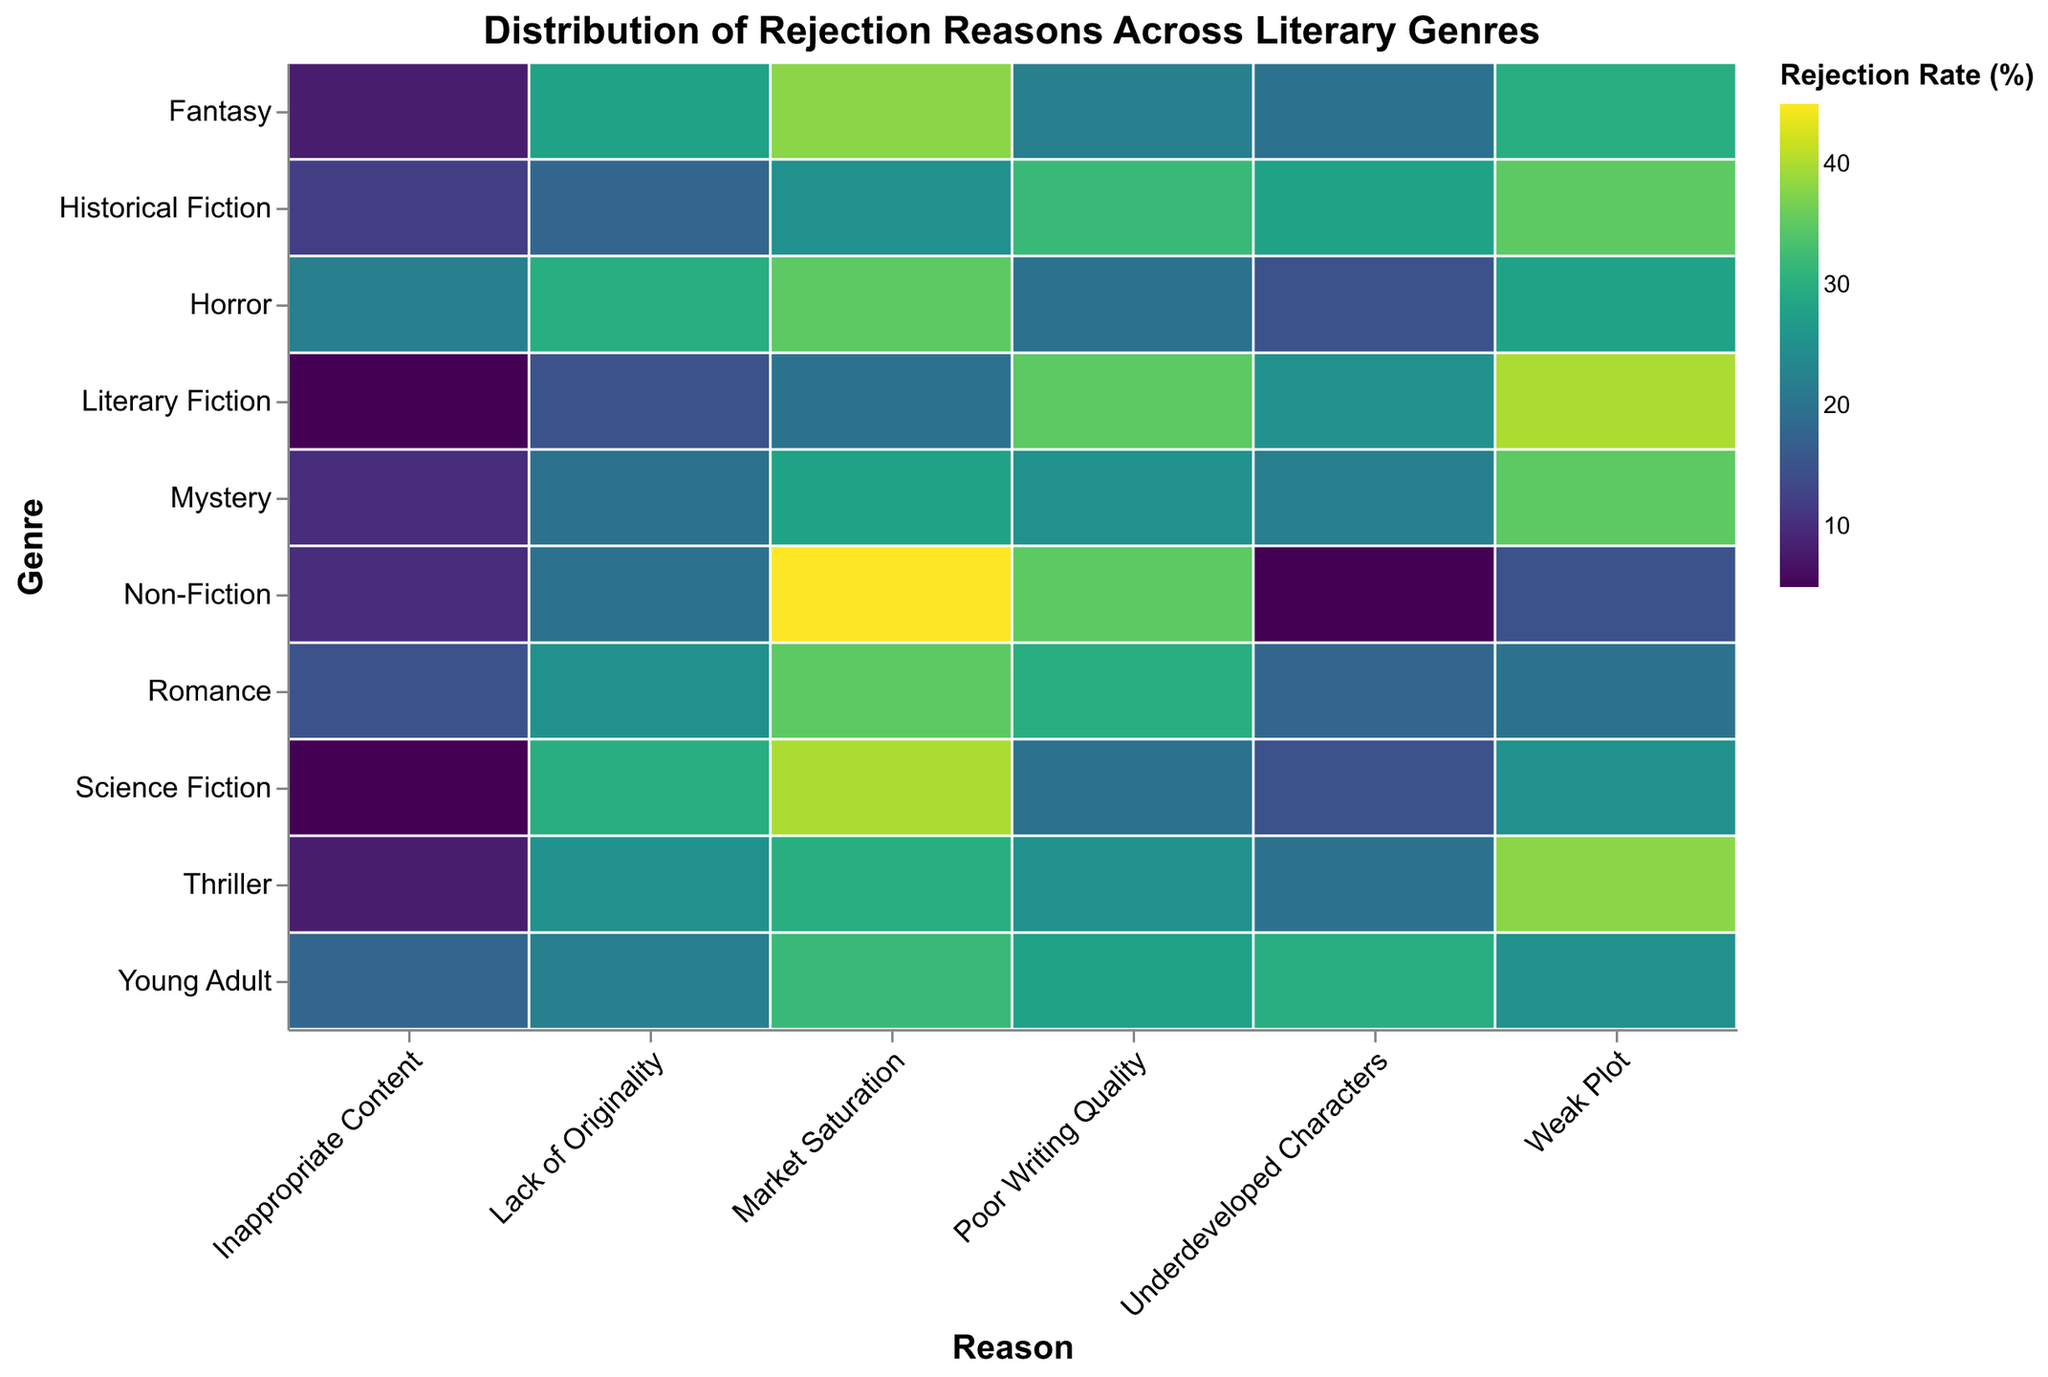what is the most common rejection reason for romance novels? look at the carpet plot and find the color that represents the highest rejection rate in the "romance" genre row. the most intense color will correspond to the highest percentage value.
Answer: market saturation which genre has the highest rate of poor writing quality as a reason for rejection? observe the column for "poor writing quality" and identify which genre has the cell with the most intense color. this will represent the highest rejection rate for that reason.
Answer: literary fiction compare the rejection rates for weak plot in mystery and fantasy genres. which one is higher? find the cells corresponding to "weak plot" in both "mystery" and "fantasy" rows and compare their colors. the more intense color indicates a higher rejection rate.
Answer: mystery does horror or young adult have a higher rate of inappropriate content as a rejection reason? look at the "inappropriate content" column and compare the cells for "horror" and "young adult." the cell with a more intense color signifies a higher rate.
Answer: horror which genre has the least issue with underdeveloped characters? examine the "underdeveloped characters" column and find the cell with the least intense color. this represents the lowest rejection rate for that reason.
Answer: non-fiction how does the lack of originality compare between science fiction and historical fiction? locate the "lack of originality" column and compare the colors for "science fiction" and "historical fiction." the more vibrant color indicates a higher rate.
Answer: science fiction what is the average rejection rate for weak plots in literary fiction, thriller, and young adult genres? sum the rejection rates for weak plots in "literary fiction" (40), "thriller" (38), and "young adult" (25). then divide by 3 to find the average: (40 + 38 + 25) / 3 = 34.33
Answer: 34.33 which are the top two genres most affected by market saturation? observe the "market saturation" column and identify the two cells with the most intense colors.
Answer: non-fiction, science fiction what is the total rejection rate for appropriate content in all genres combined? sum the percentage values for all genres under the "inappropriate content" column: 15 + 10 + 5 + 8 + 5 + 18 + 12 + 8 + 22 + 10 = 113
Answer: 113 